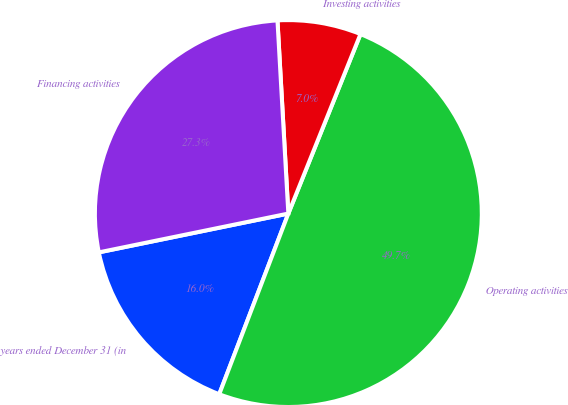<chart> <loc_0><loc_0><loc_500><loc_500><pie_chart><fcel>years ended December 31 (in<fcel>Operating activities<fcel>Investing activities<fcel>Financing activities<nl><fcel>15.97%<fcel>49.73%<fcel>6.98%<fcel>27.32%<nl></chart> 